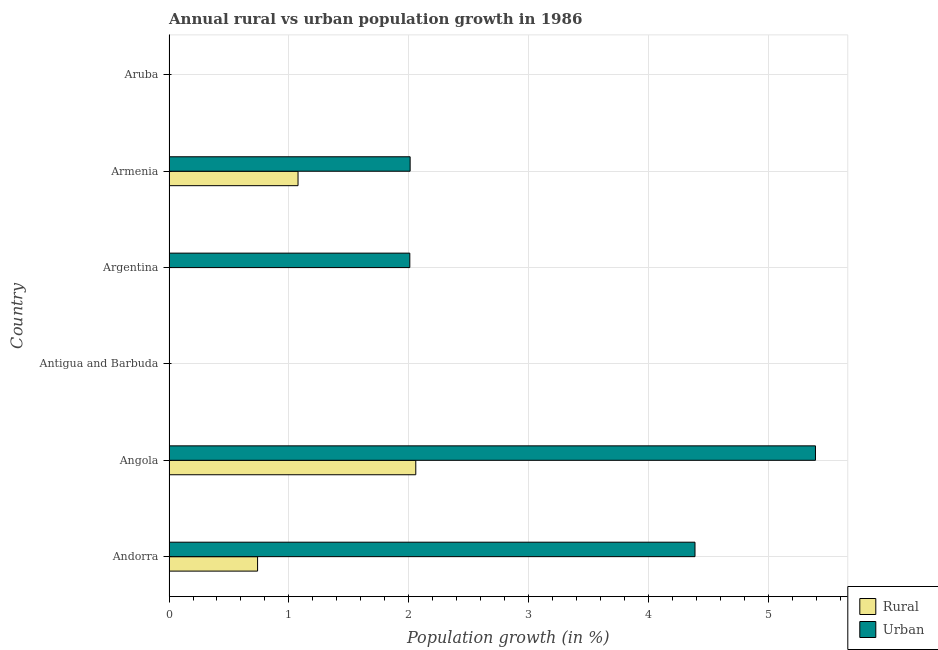How many different coloured bars are there?
Ensure brevity in your answer.  2. Are the number of bars per tick equal to the number of legend labels?
Your answer should be very brief. No. Are the number of bars on each tick of the Y-axis equal?
Give a very brief answer. No. How many bars are there on the 3rd tick from the top?
Ensure brevity in your answer.  1. What is the label of the 6th group of bars from the top?
Your response must be concise. Andorra. What is the rural population growth in Armenia?
Ensure brevity in your answer.  1.08. Across all countries, what is the maximum rural population growth?
Offer a terse response. 2.06. In which country was the rural population growth maximum?
Make the answer very short. Angola. What is the total rural population growth in the graph?
Give a very brief answer. 3.87. What is the difference between the rural population growth in Andorra and that in Armenia?
Give a very brief answer. -0.34. What is the difference between the rural population growth in Angola and the urban population growth in Andorra?
Give a very brief answer. -2.33. What is the average urban population growth per country?
Provide a succinct answer. 2.3. What is the difference between the urban population growth and rural population growth in Armenia?
Your answer should be compact. 0.93. In how many countries, is the urban population growth greater than 2 %?
Ensure brevity in your answer.  4. Is the difference between the urban population growth in Andorra and Angola greater than the difference between the rural population growth in Andorra and Angola?
Make the answer very short. Yes. What is the difference between the highest and the second highest urban population growth?
Make the answer very short. 1. What is the difference between the highest and the lowest rural population growth?
Keep it short and to the point. 2.06. Are all the bars in the graph horizontal?
Give a very brief answer. Yes. Are the values on the major ticks of X-axis written in scientific E-notation?
Your answer should be compact. No. Does the graph contain any zero values?
Your response must be concise. Yes. How many legend labels are there?
Ensure brevity in your answer.  2. How are the legend labels stacked?
Your response must be concise. Vertical. What is the title of the graph?
Make the answer very short. Annual rural vs urban population growth in 1986. Does "Old" appear as one of the legend labels in the graph?
Offer a terse response. No. What is the label or title of the X-axis?
Provide a short and direct response. Population growth (in %). What is the Population growth (in %) of Rural in Andorra?
Your response must be concise. 0.74. What is the Population growth (in %) in Urban  in Andorra?
Your answer should be very brief. 4.38. What is the Population growth (in %) in Rural in Angola?
Your response must be concise. 2.06. What is the Population growth (in %) in Urban  in Angola?
Provide a short and direct response. 5.39. What is the Population growth (in %) in Rural in Antigua and Barbuda?
Make the answer very short. 0. What is the Population growth (in %) of Rural in Argentina?
Your answer should be compact. 0. What is the Population growth (in %) of Urban  in Argentina?
Provide a succinct answer. 2.01. What is the Population growth (in %) in Rural in Armenia?
Your response must be concise. 1.08. What is the Population growth (in %) in Urban  in Armenia?
Your answer should be compact. 2.01. What is the Population growth (in %) of Urban  in Aruba?
Your response must be concise. 0. Across all countries, what is the maximum Population growth (in %) in Rural?
Ensure brevity in your answer.  2.06. Across all countries, what is the maximum Population growth (in %) of Urban ?
Your response must be concise. 5.39. Across all countries, what is the minimum Population growth (in %) of Rural?
Your response must be concise. 0. What is the total Population growth (in %) of Rural in the graph?
Offer a very short reply. 3.87. What is the total Population growth (in %) of Urban  in the graph?
Your answer should be compact. 13.79. What is the difference between the Population growth (in %) in Rural in Andorra and that in Angola?
Your response must be concise. -1.32. What is the difference between the Population growth (in %) of Urban  in Andorra and that in Angola?
Offer a terse response. -1. What is the difference between the Population growth (in %) of Urban  in Andorra and that in Argentina?
Ensure brevity in your answer.  2.38. What is the difference between the Population growth (in %) in Rural in Andorra and that in Armenia?
Give a very brief answer. -0.34. What is the difference between the Population growth (in %) in Urban  in Andorra and that in Armenia?
Provide a succinct answer. 2.37. What is the difference between the Population growth (in %) in Urban  in Angola and that in Argentina?
Your answer should be very brief. 3.38. What is the difference between the Population growth (in %) of Rural in Angola and that in Armenia?
Your answer should be compact. 0.98. What is the difference between the Population growth (in %) in Urban  in Angola and that in Armenia?
Offer a very short reply. 3.38. What is the difference between the Population growth (in %) in Urban  in Argentina and that in Armenia?
Provide a succinct answer. -0. What is the difference between the Population growth (in %) in Rural in Andorra and the Population growth (in %) in Urban  in Angola?
Your response must be concise. -4.65. What is the difference between the Population growth (in %) of Rural in Andorra and the Population growth (in %) of Urban  in Argentina?
Ensure brevity in your answer.  -1.27. What is the difference between the Population growth (in %) of Rural in Andorra and the Population growth (in %) of Urban  in Armenia?
Your response must be concise. -1.27. What is the difference between the Population growth (in %) in Rural in Angola and the Population growth (in %) in Urban  in Argentina?
Keep it short and to the point. 0.05. What is the difference between the Population growth (in %) in Rural in Angola and the Population growth (in %) in Urban  in Armenia?
Give a very brief answer. 0.05. What is the average Population growth (in %) in Rural per country?
Your answer should be compact. 0.65. What is the average Population growth (in %) of Urban  per country?
Keep it short and to the point. 2.3. What is the difference between the Population growth (in %) of Rural and Population growth (in %) of Urban  in Andorra?
Provide a succinct answer. -3.65. What is the difference between the Population growth (in %) of Rural and Population growth (in %) of Urban  in Angola?
Offer a very short reply. -3.33. What is the difference between the Population growth (in %) in Rural and Population growth (in %) in Urban  in Armenia?
Provide a short and direct response. -0.93. What is the ratio of the Population growth (in %) in Rural in Andorra to that in Angola?
Your answer should be very brief. 0.36. What is the ratio of the Population growth (in %) in Urban  in Andorra to that in Angola?
Ensure brevity in your answer.  0.81. What is the ratio of the Population growth (in %) of Urban  in Andorra to that in Argentina?
Provide a succinct answer. 2.18. What is the ratio of the Population growth (in %) of Rural in Andorra to that in Armenia?
Your response must be concise. 0.69. What is the ratio of the Population growth (in %) of Urban  in Andorra to that in Armenia?
Your response must be concise. 2.18. What is the ratio of the Population growth (in %) of Urban  in Angola to that in Argentina?
Your response must be concise. 2.68. What is the ratio of the Population growth (in %) of Rural in Angola to that in Armenia?
Your answer should be compact. 1.91. What is the ratio of the Population growth (in %) of Urban  in Angola to that in Armenia?
Provide a succinct answer. 2.68. What is the difference between the highest and the second highest Population growth (in %) of Rural?
Ensure brevity in your answer.  0.98. What is the difference between the highest and the second highest Population growth (in %) of Urban ?
Ensure brevity in your answer.  1. What is the difference between the highest and the lowest Population growth (in %) in Rural?
Provide a succinct answer. 2.06. What is the difference between the highest and the lowest Population growth (in %) in Urban ?
Provide a succinct answer. 5.39. 